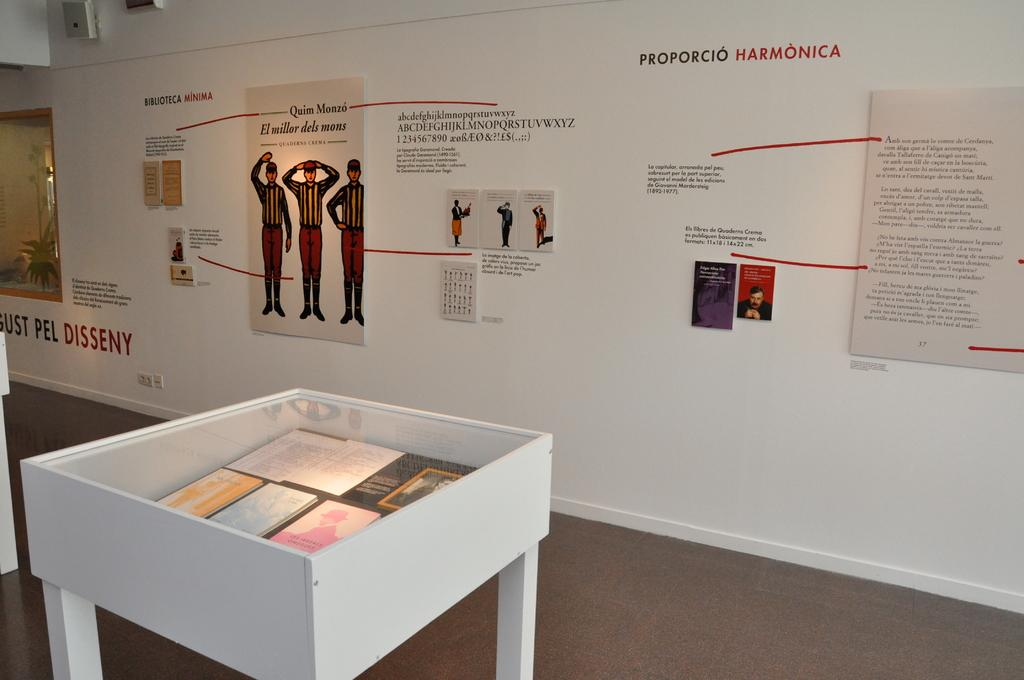What type of furniture is present in the image? There is a table in the image. What is placed on the table? There are books on the table. What can be seen on the wall in the image? There are posters on the wall. What is written or drawn on the wall? There is text visible on the wall. What type of thought can be seen traveling through the wire in the image? There is no wire present in the image, so it is not possible to observe any thoughts traveling through it. What is located at the top of the wall in the image? The provided facts do not mention anything specific about the top of the wall, so we cannot definitively answer this question. 